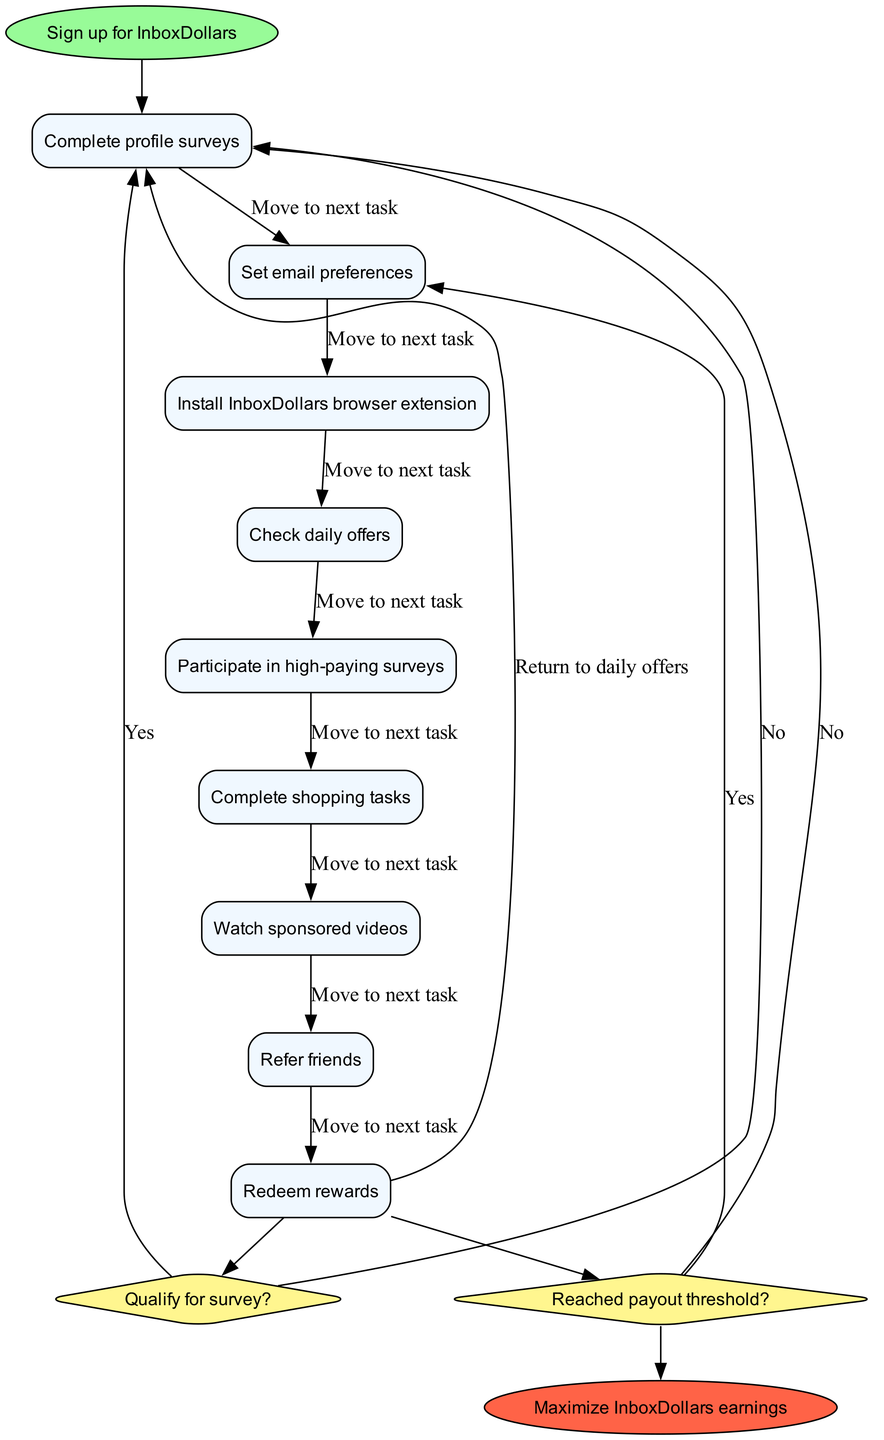What is the initial node in the diagram? The initial node in the diagram is the starting point of the customer journey, which is "Sign up for InboxDollars."
Answer: Sign up for InboxDollars How many activities are listed in the diagram? By counting the activities provided, there are a total of nine different activities listed in the diagram.
Answer: 9 What is the last activity before the first decision node? The last activity before the first decision node is "Refer friends," which follows the regular progression from the activities.
Answer: Refer friends What is the condition checked before deciding to complete a survey? The condition that must be checked before deciding whether to complete a survey is "Qualify for survey?" which determines the next step based on qualifications.
Answer: Qualify for survey? If a user does not qualify for a survey, where does the flow lead? If a user does not qualify for a survey, the flow leads them to "Check other available surveys" as indicated by the diagram.
Answer: Check other available surveys What happens if the decision node about reaching the payout threshold is "no"? If the decision node about reaching the payout threshold is "no," the flow continues to "Continue earning," indicating ongoing engagement for additional rewards.
Answer: Continue earning How many edges are used to transition from activities to the first decision node? There are five edges that connect the activities to the first decision node, which reflect the transitions between each completed activity and the decision point.
Answer: 5 What color represents the decision nodes in the diagram? The decision nodes in the diagram are represented by a fill color of "#FFF68F," which is a light yellow shade, making them distinct from other nodes.
Answer: #FFF68F What is the final node identified in the diagram? The final node identified in the diagram is "Maximize InboxDollars earnings," representing the ultimate goal of the entire customer journey process.
Answer: Maximize InboxDollars earnings 